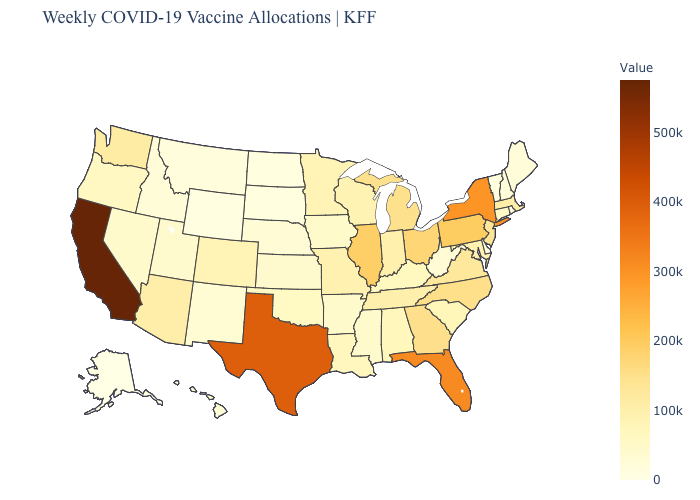Which states have the highest value in the USA?
Keep it brief. California. Does North Dakota have the lowest value in the MidWest?
Give a very brief answer. Yes. Does Arizona have the lowest value in the USA?
Answer briefly. No. Does Colorado have the lowest value in the USA?
Be succinct. No. Does Missouri have a lower value than North Carolina?
Concise answer only. Yes. Among the states that border Ohio , does West Virginia have the highest value?
Be succinct. No. Which states have the lowest value in the USA?
Give a very brief answer. Alaska. 